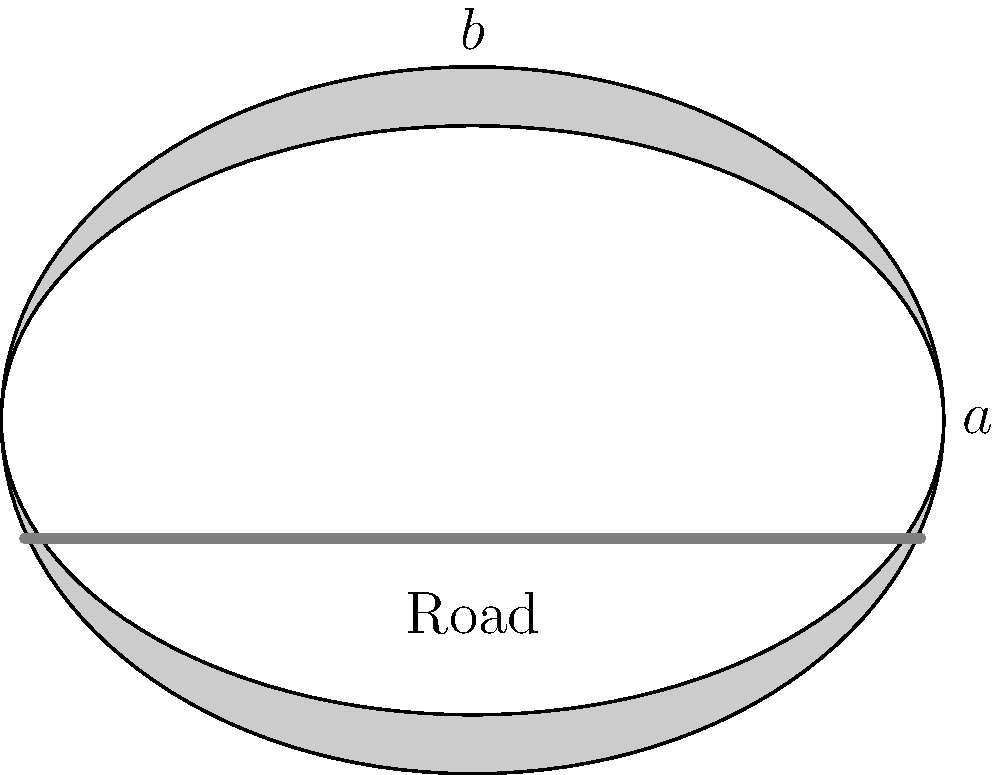As a mechanical engineer working on a scenic tunnel project in Portugal, you need to determine the most efficient cross-section shape for a tunnel using an elliptical design. The tunnel must have a fixed width of 8 meters to accommodate the road. If the cross-sectional area of the tunnel must be exactly 75 square meters, what should be the height of the tunnel (in meters) to minimize excavation costs? Express your answer in terms of $\pi$. Let's approach this step-by-step:

1) The ellipse equation is $\frac{x^2}{a^2} + \frac{y^2}{b^2} = 1$, where $a$ is the semi-major axis (half-width) and $b$ is the semi-minor axis (half-height).

2) Given the width is 8 meters, $a = 4$ meters.

3) The area of an ellipse is given by $A = \pi ab$.

4) We're told the area must be 75 square meters, so:
   $75 = \pi \cdot 4 \cdot b$

5) Solving for $b$:
   $b = \frac{75}{4\pi} = \frac{75}{4\pi}$ meters

6) To minimize excavation costs, we need to minimize the perimeter of the ellipse. The exact perimeter of an ellipse is complex, but it can be approximated by:
   $P \approx 2\pi\sqrt{\frac{a^2 + b^2}{2}}$

7) Substituting our values:
   $P \approx 2\pi\sqrt{\frac{16 + (\frac{75}{4\pi})^2}{2}}$

8) The height of the tunnel will be $2b = 2 \cdot \frac{75}{4\pi} = \frac{75}{2\pi}$ meters.
Answer: $\frac{75}{2\pi}$ meters 